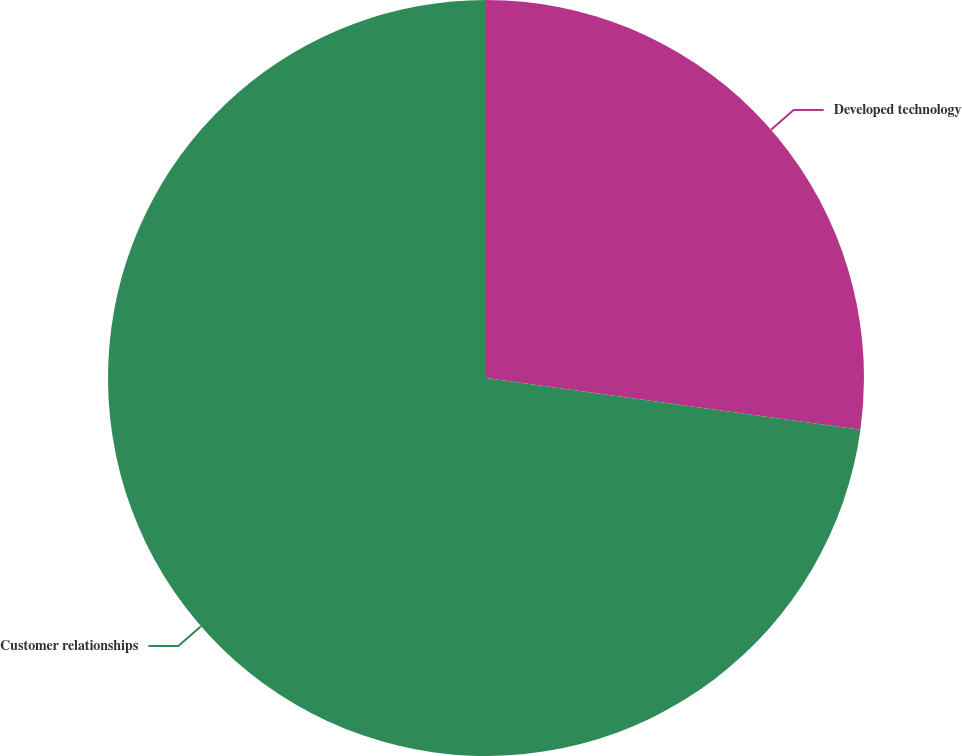Convert chart. <chart><loc_0><loc_0><loc_500><loc_500><pie_chart><fcel>Developed technology<fcel>Customer relationships<nl><fcel>27.19%<fcel>72.81%<nl></chart> 